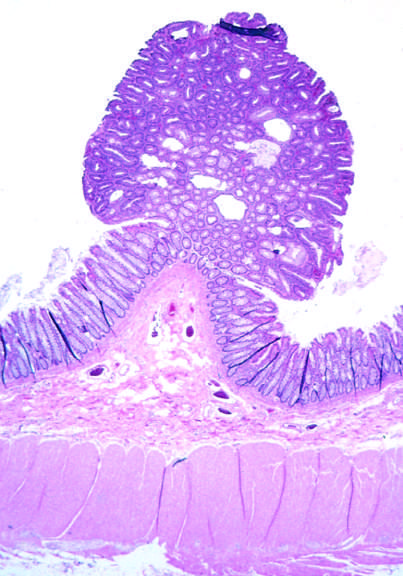what are presented in this field?
Answer the question using a single word or phrase. Small nests of epithelial cells and myxoid stroma forming cartilage and bone 